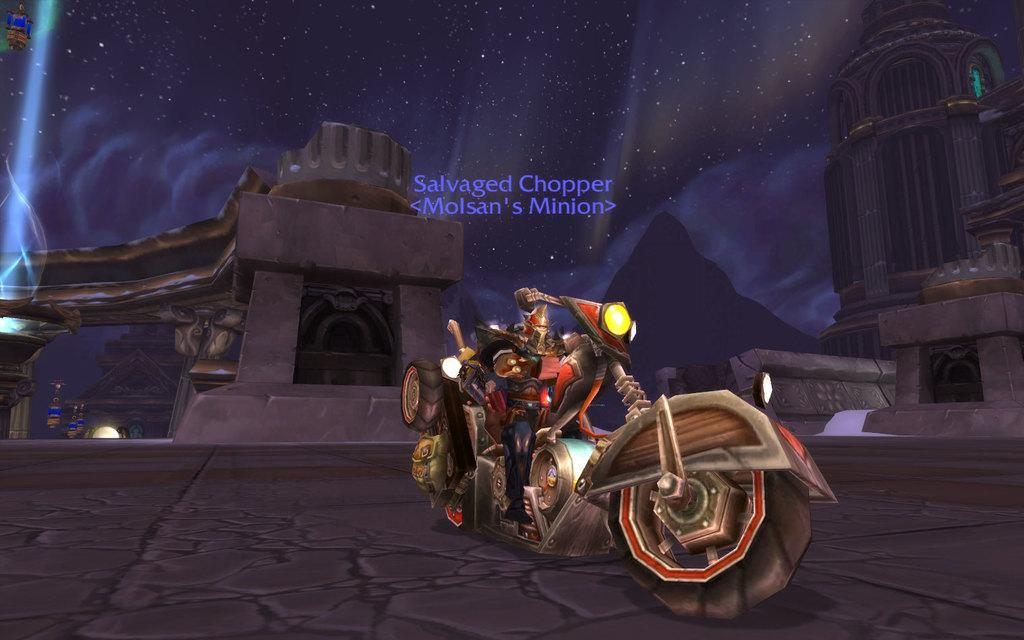What can be observed about the image itself? The image is edited. What is the main subject in the image? There is a bike on the road. What can be seen in the distance behind the bike? There are buildings in the background of the image. How does the behavior of the bike change throughout the image? The bike does not exhibit any behavior in the image, as it is a static object. 